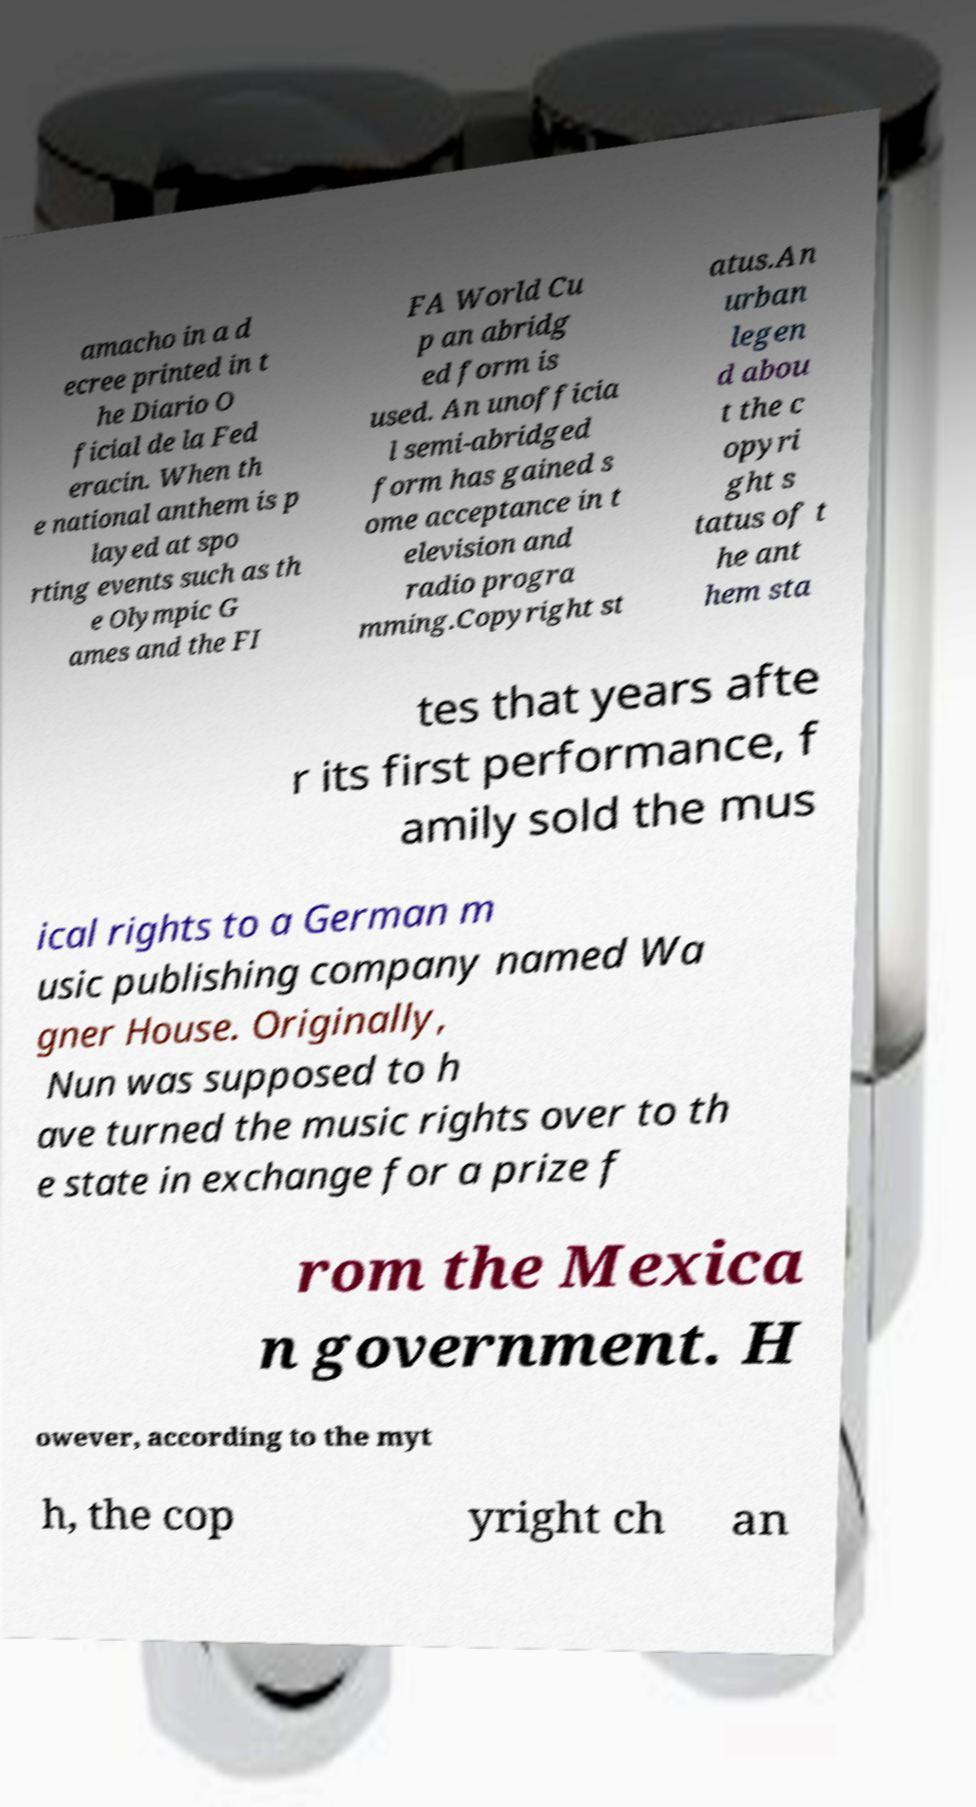Please identify and transcribe the text found in this image. amacho in a d ecree printed in t he Diario O ficial de la Fed eracin. When th e national anthem is p layed at spo rting events such as th e Olympic G ames and the FI FA World Cu p an abridg ed form is used. An unofficia l semi-abridged form has gained s ome acceptance in t elevision and radio progra mming.Copyright st atus.An urban legen d abou t the c opyri ght s tatus of t he ant hem sta tes that years afte r its first performance, f amily sold the mus ical rights to a German m usic publishing company named Wa gner House. Originally, Nun was supposed to h ave turned the music rights over to th e state in exchange for a prize f rom the Mexica n government. H owever, according to the myt h, the cop yright ch an 